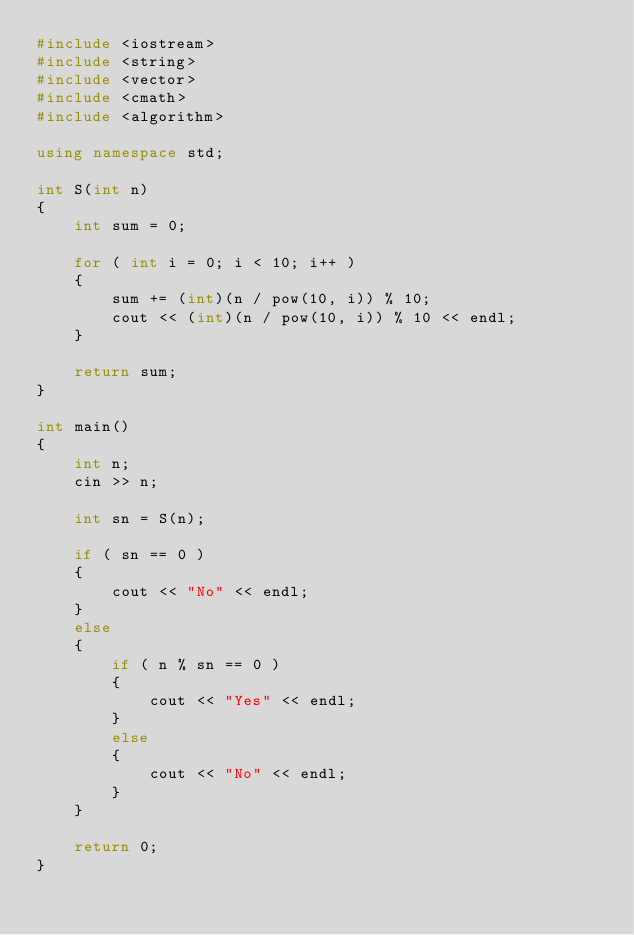Convert code to text. <code><loc_0><loc_0><loc_500><loc_500><_C++_>#include <iostream>
#include <string>
#include <vector>
#include <cmath>
#include <algorithm>

using namespace std;

int S(int n)
{
	int sum = 0;

	for ( int i = 0; i < 10; i++ )
	{
		sum += (int)(n / pow(10, i)) % 10;
		cout << (int)(n / pow(10, i)) % 10 << endl;
	}

	return sum;
}

int main()
{
	int n;
	cin >> n;

	int sn = S(n);

	if ( sn == 0 )
	{
		cout << "No" << endl;
	}
	else
	{
		if ( n % sn == 0 )
		{
			cout << "Yes" << endl;
		}
		else
		{
			cout << "No" << endl;
		}
	}

	return 0;
}
</code> 